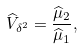Convert formula to latex. <formula><loc_0><loc_0><loc_500><loc_500>\widehat { V } _ { \delta ^ { 2 } } = \frac { \widehat { \mu } _ { 2 } } { \widehat { \mu } _ { 1 } } ,</formula> 